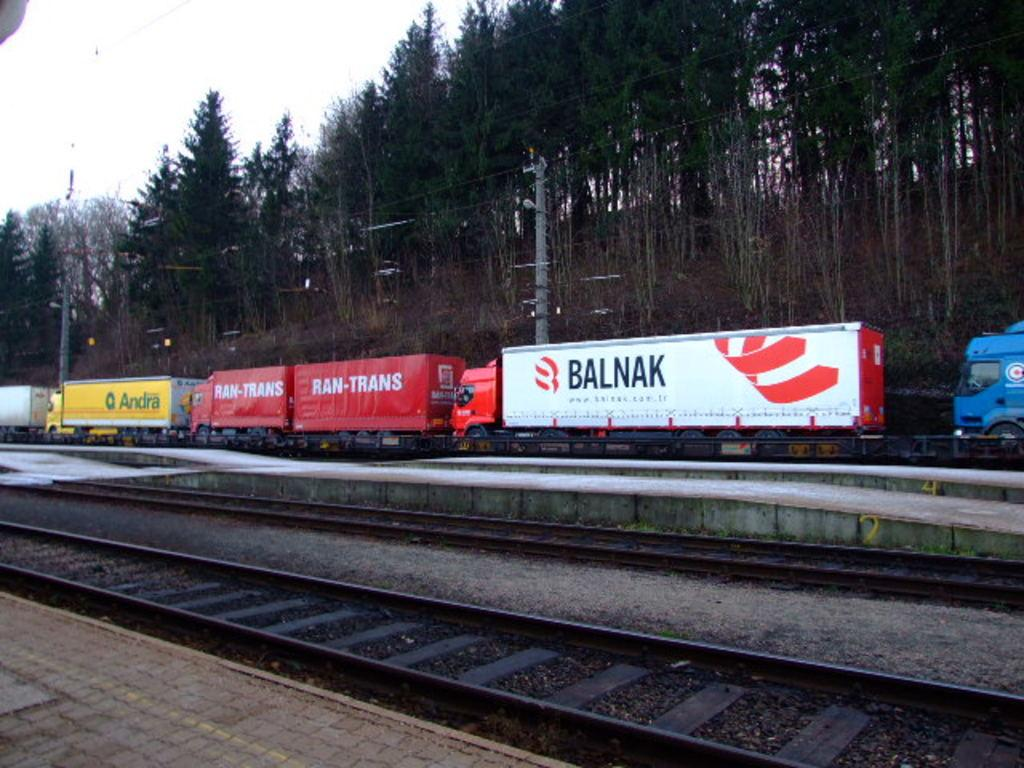What is the main feature of the image? The main feature of the image is the railway tracks. What can be seen behind the railway tracks? There are vehicles and trees behind the railway tracks. What else is present behind the trees? Electric poles with cables are present behind the trees. What is visible in the background of the image? The sky is visible behind the trees and electric poles. How many apples are hanging from the electric poles in the image? There are no apples present in the image; the electric poles have cables, not apples. Can you see any rabbits hopping around the railway tracks in the image? There are no rabbits visible in the image; the focus is on the railway tracks, vehicles, trees, electric poles, cables, and sky. 